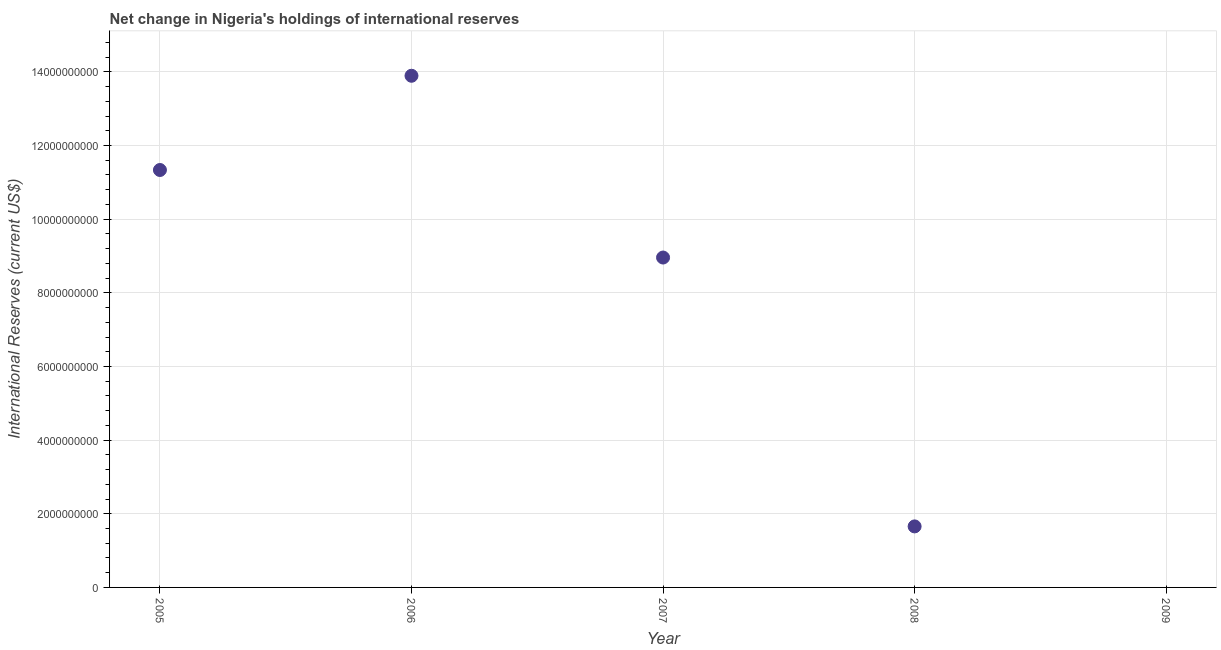Across all years, what is the maximum reserves and related items?
Give a very brief answer. 1.39e+1. In which year was the reserves and related items maximum?
Provide a succinct answer. 2006. What is the sum of the reserves and related items?
Your answer should be compact. 3.58e+1. What is the difference between the reserves and related items in 2005 and 2006?
Offer a very short reply. -2.56e+09. What is the average reserves and related items per year?
Provide a succinct answer. 7.17e+09. What is the median reserves and related items?
Your response must be concise. 8.96e+09. In how many years, is the reserves and related items greater than 13600000000 US$?
Your answer should be very brief. 1. What is the ratio of the reserves and related items in 2006 to that in 2007?
Offer a terse response. 1.55. Is the reserves and related items in 2005 less than that in 2006?
Keep it short and to the point. Yes. Is the difference between the reserves and related items in 2006 and 2008 greater than the difference between any two years?
Offer a very short reply. No. What is the difference between the highest and the second highest reserves and related items?
Provide a short and direct response. 2.56e+09. Is the sum of the reserves and related items in 2006 and 2007 greater than the maximum reserves and related items across all years?
Give a very brief answer. Yes. What is the difference between the highest and the lowest reserves and related items?
Provide a succinct answer. 1.39e+1. How many dotlines are there?
Ensure brevity in your answer.  1. Does the graph contain any zero values?
Offer a terse response. Yes. What is the title of the graph?
Make the answer very short. Net change in Nigeria's holdings of international reserves. What is the label or title of the X-axis?
Provide a succinct answer. Year. What is the label or title of the Y-axis?
Keep it short and to the point. International Reserves (current US$). What is the International Reserves (current US$) in 2005?
Provide a short and direct response. 1.13e+1. What is the International Reserves (current US$) in 2006?
Offer a very short reply. 1.39e+1. What is the International Reserves (current US$) in 2007?
Give a very brief answer. 8.96e+09. What is the International Reserves (current US$) in 2008?
Make the answer very short. 1.66e+09. What is the International Reserves (current US$) in 2009?
Your answer should be compact. 0. What is the difference between the International Reserves (current US$) in 2005 and 2006?
Your response must be concise. -2.56e+09. What is the difference between the International Reserves (current US$) in 2005 and 2007?
Ensure brevity in your answer.  2.38e+09. What is the difference between the International Reserves (current US$) in 2005 and 2008?
Offer a very short reply. 9.68e+09. What is the difference between the International Reserves (current US$) in 2006 and 2007?
Offer a terse response. 4.94e+09. What is the difference between the International Reserves (current US$) in 2006 and 2008?
Keep it short and to the point. 1.22e+1. What is the difference between the International Reserves (current US$) in 2007 and 2008?
Provide a short and direct response. 7.30e+09. What is the ratio of the International Reserves (current US$) in 2005 to that in 2006?
Ensure brevity in your answer.  0.82. What is the ratio of the International Reserves (current US$) in 2005 to that in 2007?
Offer a terse response. 1.26. What is the ratio of the International Reserves (current US$) in 2005 to that in 2008?
Offer a very short reply. 6.84. What is the ratio of the International Reserves (current US$) in 2006 to that in 2007?
Your response must be concise. 1.55. What is the ratio of the International Reserves (current US$) in 2006 to that in 2008?
Your answer should be compact. 8.38. What is the ratio of the International Reserves (current US$) in 2007 to that in 2008?
Ensure brevity in your answer.  5.41. 